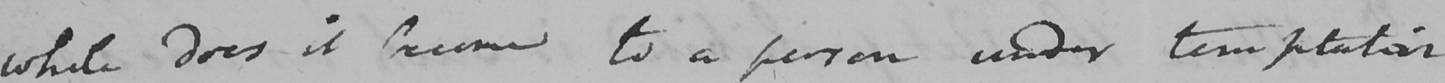Transcribe the text shown in this historical manuscript line. while does it become to a person under temptation 